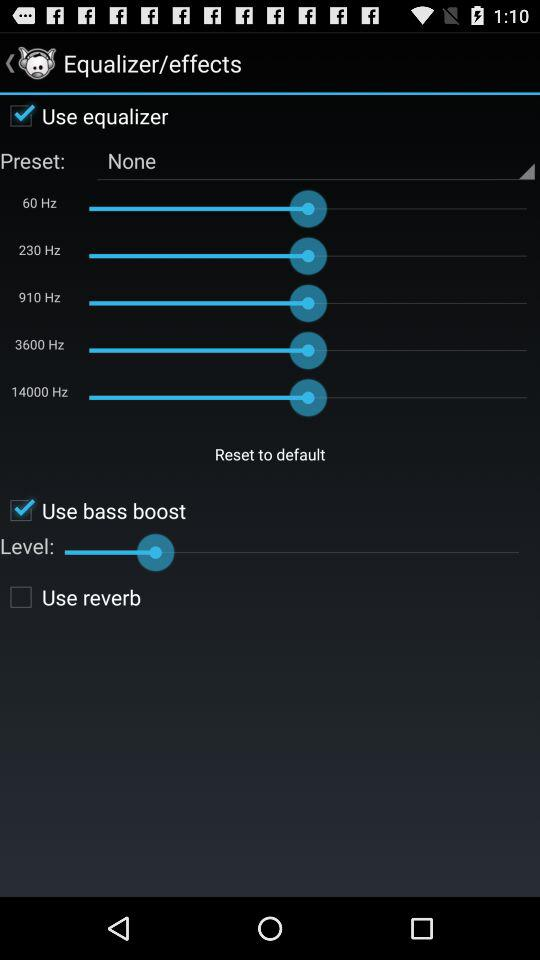Is "Use equalizer" checked or unchecked?
Answer the question using a single word or phrase. It is "checked". 